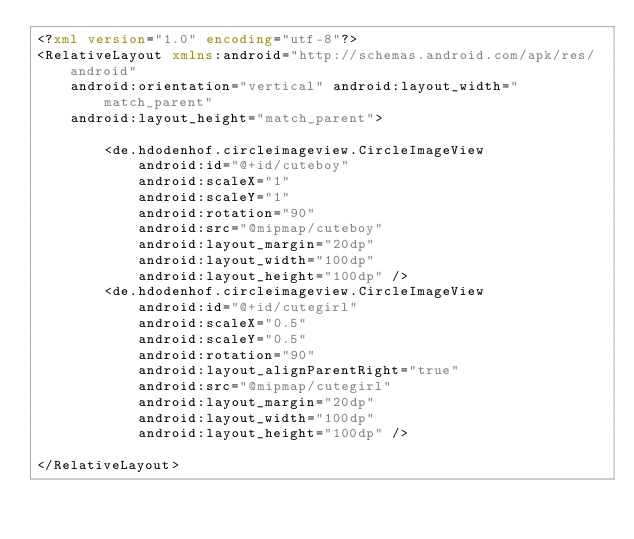Convert code to text. <code><loc_0><loc_0><loc_500><loc_500><_XML_><?xml version="1.0" encoding="utf-8"?>
<RelativeLayout xmlns:android="http://schemas.android.com/apk/res/android"
    android:orientation="vertical" android:layout_width="match_parent"
    android:layout_height="match_parent">

        <de.hdodenhof.circleimageview.CircleImageView
            android:id="@+id/cuteboy"
            android:scaleX="1"
            android:scaleY="1"
            android:rotation="90"
            android:src="@mipmap/cuteboy"
            android:layout_margin="20dp"
            android:layout_width="100dp"
            android:layout_height="100dp" />
        <de.hdodenhof.circleimageview.CircleImageView
            android:id="@+id/cutegirl"
            android:scaleX="0.5"
            android:scaleY="0.5"
            android:rotation="90"
            android:layout_alignParentRight="true"
            android:src="@mipmap/cutegirl"
            android:layout_margin="20dp"
            android:layout_width="100dp"
            android:layout_height="100dp" />

</RelativeLayout></code> 